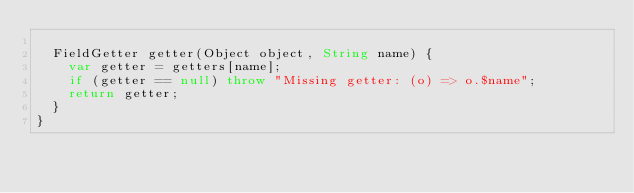<code> <loc_0><loc_0><loc_500><loc_500><_Dart_>
  FieldGetter getter(Object object, String name) {
    var getter = getters[name];
    if (getter == null) throw "Missing getter: (o) => o.$name";
    return getter;
  }
}
</code> 